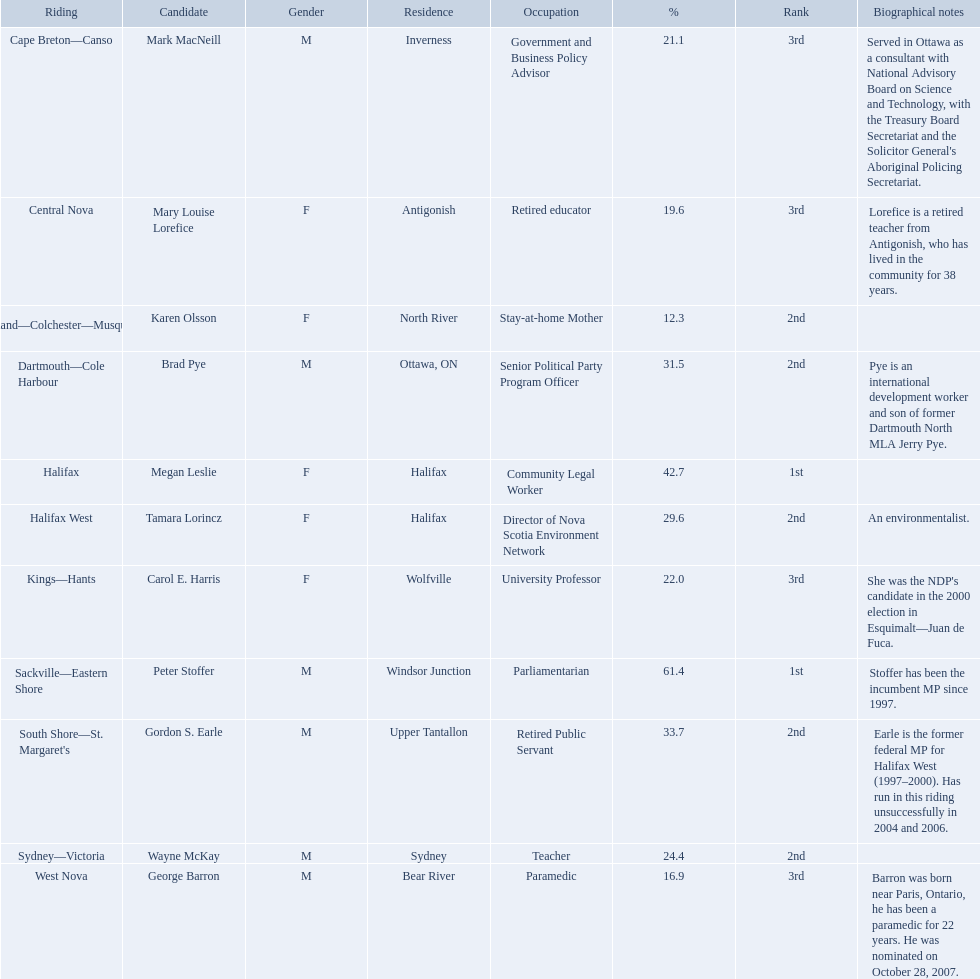Which candidates have the four lowest amount of votes Mark MacNeill, Mary Louise Lorefice, Karen Olsson, George Barron. Out of the following, who has the third most? Mark MacNeill. Who are all the candidates? Mark MacNeill, Mary Louise Lorefice, Karen Olsson, Brad Pye, Megan Leslie, Tamara Lorincz, Carol E. Harris, Peter Stoffer, Gordon S. Earle, Wayne McKay, George Barron. Would you be able to parse every entry in this table? {'header': ['Riding', 'Candidate', 'Gender', 'Residence', 'Occupation', '%', 'Rank', 'Biographical notes'], 'rows': [['Cape Breton—Canso', 'Mark MacNeill', 'M', 'Inverness', 'Government and Business Policy Advisor', '21.1', '3rd', "Served in Ottawa as a consultant with National Advisory Board on Science and Technology, with the Treasury Board Secretariat and the Solicitor General's Aboriginal Policing Secretariat."], ['Central Nova', 'Mary Louise Lorefice', 'F', 'Antigonish', 'Retired educator', '19.6', '3rd', 'Lorefice is a retired teacher from Antigonish, who has lived in the community for 38 years.'], ['Cumberland—Colchester—Musquodoboit Valley', 'Karen Olsson', 'F', 'North River', 'Stay-at-home Mother', '12.3', '2nd', ''], ['Dartmouth—Cole Harbour', 'Brad Pye', 'M', 'Ottawa, ON', 'Senior Political Party Program Officer', '31.5', '2nd', 'Pye is an international development worker and son of former Dartmouth North MLA Jerry Pye.'], ['Halifax', 'Megan Leslie', 'F', 'Halifax', 'Community Legal Worker', '42.7', '1st', ''], ['Halifax West', 'Tamara Lorincz', 'F', 'Halifax', 'Director of Nova Scotia Environment Network', '29.6', '2nd', 'An environmentalist.'], ['Kings—Hants', 'Carol E. Harris', 'F', 'Wolfville', 'University Professor', '22.0', '3rd', "She was the NDP's candidate in the 2000 election in Esquimalt—Juan de Fuca."], ['Sackville—Eastern Shore', 'Peter Stoffer', 'M', 'Windsor Junction', 'Parliamentarian', '61.4', '1st', 'Stoffer has been the incumbent MP since 1997.'], ["South Shore—St. Margaret's", 'Gordon S. Earle', 'M', 'Upper Tantallon', 'Retired Public Servant', '33.7', '2nd', 'Earle is the former federal MP for Halifax West (1997–2000). Has run in this riding unsuccessfully in 2004 and 2006.'], ['Sydney—Victoria', 'Wayne McKay', 'M', 'Sydney', 'Teacher', '24.4', '2nd', ''], ['West Nova', 'George Barron', 'M', 'Bear River', 'Paramedic', '16.9', '3rd', 'Barron was born near Paris, Ontario, he has been a paramedic for 22 years. He was nominated on October 28, 2007.']]} How many votes did they receive? 7,660, 7,659, 4,874, 12,793, 19,252, 12,201, 8,291, 24,279, 13,456, 8,559, 7,097. And of those, how many were for megan leslie? 19,252. What new democratic party candidates ran in the 2008 canadian federal election? Mark MacNeill, Mary Louise Lorefice, Karen Olsson, Brad Pye, Megan Leslie, Tamara Lorincz, Carol E. Harris, Peter Stoffer, Gordon S. Earle, Wayne McKay, George Barron. Of these candidates, which are female? Mary Louise Lorefice, Karen Olsson, Megan Leslie, Tamara Lorincz, Carol E. Harris. Which of these candidates resides in halifax? Megan Leslie, Tamara Lorincz. Of the remaining two, which was ranked 1st? Megan Leslie. How many votes did she get? 19,252. 